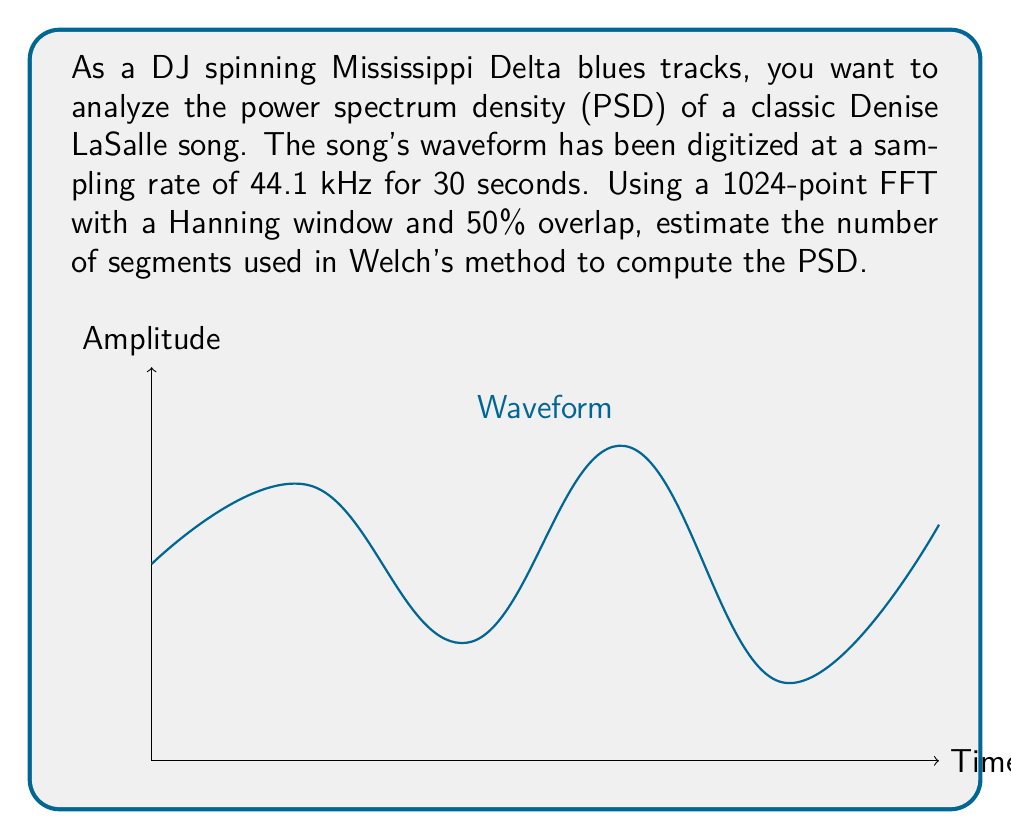Teach me how to tackle this problem. Let's approach this step-by-step:

1) First, calculate the total number of samples:
   $N = \text{sampling rate} \times \text{duration}$
   $N = 44100 \text{ Hz} \times 30 \text{ s} = 1,323,000 \text{ samples}$

2) The FFT size is 1024 points, but we're using 50% overlap. This means each segment will advance by 512 points.

3) To calculate the number of segments, we use the formula:
   $\text{Number of segments} = \left\lfloor\frac{N - L}{L/2}\right\rfloor + 1$
   Where $N$ is the total number of samples and $L$ is the FFT size.

4) Plugging in our values:
   $\text{Number of segments} = \left\lfloor\frac{1,323,000 - 1024}{1024/2}\right\rfloor + 1$
   
5) Simplify:
   $= \left\lfloor\frac{1,321,976}{512}\right\rfloor + 1$
   $= \left\lfloor 2581.984375\right\rfloor + 1$
   $= 2581 + 1$
   $= 2582$

Therefore, Welch's method will use 2582 segments to estimate the PSD of the Mississippi Delta blues track.
Answer: 2582 segments 